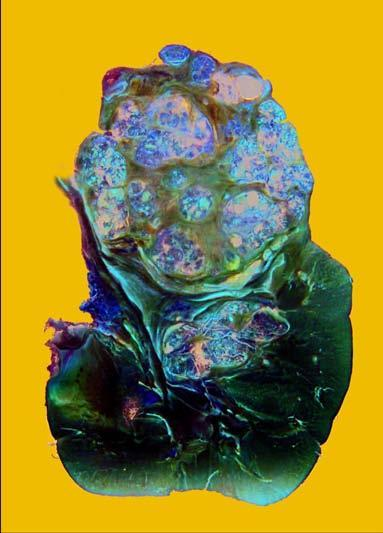does rest of the kidney have reniform contour?
Answer the question using a single word or phrase. Yes 